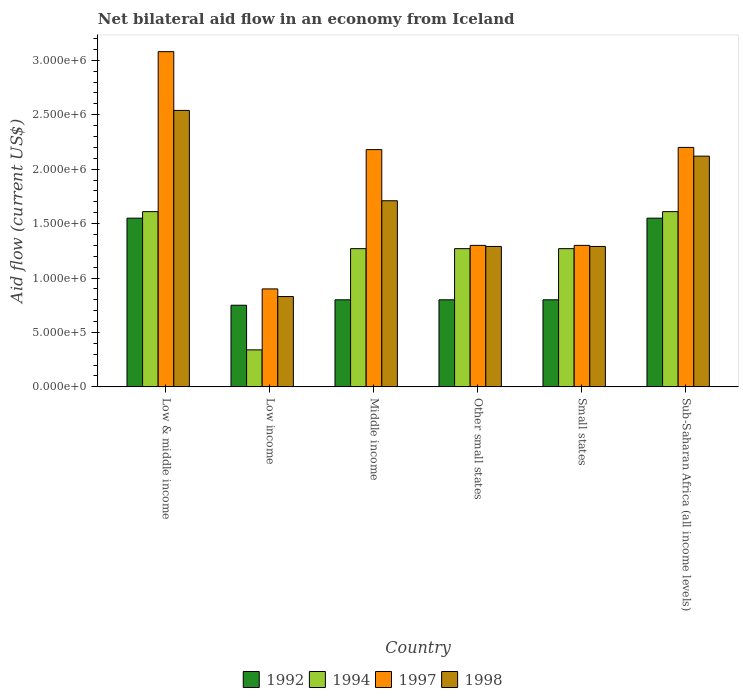How many groups of bars are there?
Provide a succinct answer. 6. Are the number of bars per tick equal to the number of legend labels?
Your answer should be compact. Yes. Are the number of bars on each tick of the X-axis equal?
Your response must be concise. Yes. How many bars are there on the 6th tick from the left?
Offer a terse response. 4. What is the label of the 5th group of bars from the left?
Your answer should be very brief. Small states. What is the net bilateral aid flow in 1997 in Small states?
Give a very brief answer. 1.30e+06. Across all countries, what is the maximum net bilateral aid flow in 1994?
Give a very brief answer. 1.61e+06. Across all countries, what is the minimum net bilateral aid flow in 1992?
Keep it short and to the point. 7.50e+05. What is the total net bilateral aid flow in 1992 in the graph?
Provide a succinct answer. 6.25e+06. What is the difference between the net bilateral aid flow in 1994 in Middle income and that in Other small states?
Keep it short and to the point. 0. What is the average net bilateral aid flow in 1997 per country?
Make the answer very short. 1.83e+06. What is the difference between the net bilateral aid flow of/in 1998 and net bilateral aid flow of/in 1997 in Low income?
Make the answer very short. -7.00e+04. What is the ratio of the net bilateral aid flow in 1992 in Middle income to that in Sub-Saharan Africa (all income levels)?
Your response must be concise. 0.52. Is the difference between the net bilateral aid flow in 1998 in Low income and Small states greater than the difference between the net bilateral aid flow in 1997 in Low income and Small states?
Offer a terse response. No. What is the difference between the highest and the second highest net bilateral aid flow in 1998?
Offer a very short reply. 4.20e+05. What is the difference between the highest and the lowest net bilateral aid flow in 1998?
Your response must be concise. 1.71e+06. In how many countries, is the net bilateral aid flow in 1994 greater than the average net bilateral aid flow in 1994 taken over all countries?
Offer a terse response. 5. Is it the case that in every country, the sum of the net bilateral aid flow in 1998 and net bilateral aid flow in 1997 is greater than the sum of net bilateral aid flow in 1992 and net bilateral aid flow in 1994?
Keep it short and to the point. No. What does the 1st bar from the left in Other small states represents?
Make the answer very short. 1992. What does the 4th bar from the right in Low income represents?
Ensure brevity in your answer.  1992. How many countries are there in the graph?
Your response must be concise. 6. What is the difference between two consecutive major ticks on the Y-axis?
Your answer should be very brief. 5.00e+05. How many legend labels are there?
Provide a succinct answer. 4. What is the title of the graph?
Give a very brief answer. Net bilateral aid flow in an economy from Iceland. What is the label or title of the X-axis?
Your answer should be very brief. Country. What is the Aid flow (current US$) of 1992 in Low & middle income?
Your answer should be very brief. 1.55e+06. What is the Aid flow (current US$) of 1994 in Low & middle income?
Provide a short and direct response. 1.61e+06. What is the Aid flow (current US$) in 1997 in Low & middle income?
Your response must be concise. 3.08e+06. What is the Aid flow (current US$) in 1998 in Low & middle income?
Offer a very short reply. 2.54e+06. What is the Aid flow (current US$) in 1992 in Low income?
Provide a succinct answer. 7.50e+05. What is the Aid flow (current US$) of 1994 in Low income?
Give a very brief answer. 3.40e+05. What is the Aid flow (current US$) in 1997 in Low income?
Make the answer very short. 9.00e+05. What is the Aid flow (current US$) of 1998 in Low income?
Your response must be concise. 8.30e+05. What is the Aid flow (current US$) of 1994 in Middle income?
Your answer should be very brief. 1.27e+06. What is the Aid flow (current US$) of 1997 in Middle income?
Ensure brevity in your answer.  2.18e+06. What is the Aid flow (current US$) of 1998 in Middle income?
Offer a very short reply. 1.71e+06. What is the Aid flow (current US$) of 1992 in Other small states?
Keep it short and to the point. 8.00e+05. What is the Aid flow (current US$) in 1994 in Other small states?
Keep it short and to the point. 1.27e+06. What is the Aid flow (current US$) of 1997 in Other small states?
Keep it short and to the point. 1.30e+06. What is the Aid flow (current US$) of 1998 in Other small states?
Make the answer very short. 1.29e+06. What is the Aid flow (current US$) in 1992 in Small states?
Your response must be concise. 8.00e+05. What is the Aid flow (current US$) of 1994 in Small states?
Give a very brief answer. 1.27e+06. What is the Aid flow (current US$) of 1997 in Small states?
Keep it short and to the point. 1.30e+06. What is the Aid flow (current US$) in 1998 in Small states?
Give a very brief answer. 1.29e+06. What is the Aid flow (current US$) of 1992 in Sub-Saharan Africa (all income levels)?
Offer a terse response. 1.55e+06. What is the Aid flow (current US$) of 1994 in Sub-Saharan Africa (all income levels)?
Provide a succinct answer. 1.61e+06. What is the Aid flow (current US$) in 1997 in Sub-Saharan Africa (all income levels)?
Provide a succinct answer. 2.20e+06. What is the Aid flow (current US$) of 1998 in Sub-Saharan Africa (all income levels)?
Provide a succinct answer. 2.12e+06. Across all countries, what is the maximum Aid flow (current US$) of 1992?
Offer a terse response. 1.55e+06. Across all countries, what is the maximum Aid flow (current US$) in 1994?
Give a very brief answer. 1.61e+06. Across all countries, what is the maximum Aid flow (current US$) of 1997?
Give a very brief answer. 3.08e+06. Across all countries, what is the maximum Aid flow (current US$) of 1998?
Give a very brief answer. 2.54e+06. Across all countries, what is the minimum Aid flow (current US$) in 1992?
Provide a short and direct response. 7.50e+05. Across all countries, what is the minimum Aid flow (current US$) of 1994?
Give a very brief answer. 3.40e+05. Across all countries, what is the minimum Aid flow (current US$) in 1998?
Your answer should be compact. 8.30e+05. What is the total Aid flow (current US$) in 1992 in the graph?
Give a very brief answer. 6.25e+06. What is the total Aid flow (current US$) of 1994 in the graph?
Offer a terse response. 7.37e+06. What is the total Aid flow (current US$) of 1997 in the graph?
Your answer should be compact. 1.10e+07. What is the total Aid flow (current US$) of 1998 in the graph?
Offer a very short reply. 9.78e+06. What is the difference between the Aid flow (current US$) of 1994 in Low & middle income and that in Low income?
Provide a short and direct response. 1.27e+06. What is the difference between the Aid flow (current US$) of 1997 in Low & middle income and that in Low income?
Offer a terse response. 2.18e+06. What is the difference between the Aid flow (current US$) of 1998 in Low & middle income and that in Low income?
Your answer should be very brief. 1.71e+06. What is the difference between the Aid flow (current US$) in 1992 in Low & middle income and that in Middle income?
Provide a short and direct response. 7.50e+05. What is the difference between the Aid flow (current US$) in 1994 in Low & middle income and that in Middle income?
Ensure brevity in your answer.  3.40e+05. What is the difference between the Aid flow (current US$) in 1997 in Low & middle income and that in Middle income?
Offer a very short reply. 9.00e+05. What is the difference between the Aid flow (current US$) in 1998 in Low & middle income and that in Middle income?
Give a very brief answer. 8.30e+05. What is the difference between the Aid flow (current US$) in 1992 in Low & middle income and that in Other small states?
Your answer should be very brief. 7.50e+05. What is the difference between the Aid flow (current US$) in 1994 in Low & middle income and that in Other small states?
Make the answer very short. 3.40e+05. What is the difference between the Aid flow (current US$) of 1997 in Low & middle income and that in Other small states?
Provide a succinct answer. 1.78e+06. What is the difference between the Aid flow (current US$) in 1998 in Low & middle income and that in Other small states?
Your answer should be compact. 1.25e+06. What is the difference between the Aid flow (current US$) of 1992 in Low & middle income and that in Small states?
Provide a short and direct response. 7.50e+05. What is the difference between the Aid flow (current US$) of 1997 in Low & middle income and that in Small states?
Ensure brevity in your answer.  1.78e+06. What is the difference between the Aid flow (current US$) of 1998 in Low & middle income and that in Small states?
Keep it short and to the point. 1.25e+06. What is the difference between the Aid flow (current US$) of 1997 in Low & middle income and that in Sub-Saharan Africa (all income levels)?
Offer a very short reply. 8.80e+05. What is the difference between the Aid flow (current US$) in 1998 in Low & middle income and that in Sub-Saharan Africa (all income levels)?
Keep it short and to the point. 4.20e+05. What is the difference between the Aid flow (current US$) in 1992 in Low income and that in Middle income?
Your answer should be compact. -5.00e+04. What is the difference between the Aid flow (current US$) of 1994 in Low income and that in Middle income?
Ensure brevity in your answer.  -9.30e+05. What is the difference between the Aid flow (current US$) in 1997 in Low income and that in Middle income?
Provide a succinct answer. -1.28e+06. What is the difference between the Aid flow (current US$) of 1998 in Low income and that in Middle income?
Make the answer very short. -8.80e+05. What is the difference between the Aid flow (current US$) in 1992 in Low income and that in Other small states?
Provide a short and direct response. -5.00e+04. What is the difference between the Aid flow (current US$) of 1994 in Low income and that in Other small states?
Provide a short and direct response. -9.30e+05. What is the difference between the Aid flow (current US$) of 1997 in Low income and that in Other small states?
Offer a terse response. -4.00e+05. What is the difference between the Aid flow (current US$) in 1998 in Low income and that in Other small states?
Your answer should be compact. -4.60e+05. What is the difference between the Aid flow (current US$) in 1994 in Low income and that in Small states?
Offer a very short reply. -9.30e+05. What is the difference between the Aid flow (current US$) in 1997 in Low income and that in Small states?
Your answer should be compact. -4.00e+05. What is the difference between the Aid flow (current US$) in 1998 in Low income and that in Small states?
Provide a succinct answer. -4.60e+05. What is the difference between the Aid flow (current US$) of 1992 in Low income and that in Sub-Saharan Africa (all income levels)?
Make the answer very short. -8.00e+05. What is the difference between the Aid flow (current US$) in 1994 in Low income and that in Sub-Saharan Africa (all income levels)?
Ensure brevity in your answer.  -1.27e+06. What is the difference between the Aid flow (current US$) in 1997 in Low income and that in Sub-Saharan Africa (all income levels)?
Offer a terse response. -1.30e+06. What is the difference between the Aid flow (current US$) of 1998 in Low income and that in Sub-Saharan Africa (all income levels)?
Give a very brief answer. -1.29e+06. What is the difference between the Aid flow (current US$) of 1992 in Middle income and that in Other small states?
Ensure brevity in your answer.  0. What is the difference between the Aid flow (current US$) in 1997 in Middle income and that in Other small states?
Keep it short and to the point. 8.80e+05. What is the difference between the Aid flow (current US$) of 1998 in Middle income and that in Other small states?
Ensure brevity in your answer.  4.20e+05. What is the difference between the Aid flow (current US$) in 1992 in Middle income and that in Small states?
Offer a terse response. 0. What is the difference between the Aid flow (current US$) in 1994 in Middle income and that in Small states?
Provide a short and direct response. 0. What is the difference between the Aid flow (current US$) in 1997 in Middle income and that in Small states?
Your answer should be compact. 8.80e+05. What is the difference between the Aid flow (current US$) of 1992 in Middle income and that in Sub-Saharan Africa (all income levels)?
Your answer should be compact. -7.50e+05. What is the difference between the Aid flow (current US$) in 1998 in Middle income and that in Sub-Saharan Africa (all income levels)?
Offer a very short reply. -4.10e+05. What is the difference between the Aid flow (current US$) in 1994 in Other small states and that in Small states?
Provide a short and direct response. 0. What is the difference between the Aid flow (current US$) in 1997 in Other small states and that in Small states?
Give a very brief answer. 0. What is the difference between the Aid flow (current US$) in 1992 in Other small states and that in Sub-Saharan Africa (all income levels)?
Give a very brief answer. -7.50e+05. What is the difference between the Aid flow (current US$) of 1997 in Other small states and that in Sub-Saharan Africa (all income levels)?
Offer a very short reply. -9.00e+05. What is the difference between the Aid flow (current US$) in 1998 in Other small states and that in Sub-Saharan Africa (all income levels)?
Provide a succinct answer. -8.30e+05. What is the difference between the Aid flow (current US$) of 1992 in Small states and that in Sub-Saharan Africa (all income levels)?
Give a very brief answer. -7.50e+05. What is the difference between the Aid flow (current US$) of 1997 in Small states and that in Sub-Saharan Africa (all income levels)?
Your answer should be very brief. -9.00e+05. What is the difference between the Aid flow (current US$) of 1998 in Small states and that in Sub-Saharan Africa (all income levels)?
Your answer should be compact. -8.30e+05. What is the difference between the Aid flow (current US$) in 1992 in Low & middle income and the Aid flow (current US$) in 1994 in Low income?
Your answer should be very brief. 1.21e+06. What is the difference between the Aid flow (current US$) of 1992 in Low & middle income and the Aid flow (current US$) of 1997 in Low income?
Offer a terse response. 6.50e+05. What is the difference between the Aid flow (current US$) of 1992 in Low & middle income and the Aid flow (current US$) of 1998 in Low income?
Give a very brief answer. 7.20e+05. What is the difference between the Aid flow (current US$) in 1994 in Low & middle income and the Aid flow (current US$) in 1997 in Low income?
Offer a terse response. 7.10e+05. What is the difference between the Aid flow (current US$) of 1994 in Low & middle income and the Aid flow (current US$) of 1998 in Low income?
Offer a very short reply. 7.80e+05. What is the difference between the Aid flow (current US$) of 1997 in Low & middle income and the Aid flow (current US$) of 1998 in Low income?
Keep it short and to the point. 2.25e+06. What is the difference between the Aid flow (current US$) in 1992 in Low & middle income and the Aid flow (current US$) in 1994 in Middle income?
Offer a terse response. 2.80e+05. What is the difference between the Aid flow (current US$) in 1992 in Low & middle income and the Aid flow (current US$) in 1997 in Middle income?
Provide a succinct answer. -6.30e+05. What is the difference between the Aid flow (current US$) of 1992 in Low & middle income and the Aid flow (current US$) of 1998 in Middle income?
Provide a short and direct response. -1.60e+05. What is the difference between the Aid flow (current US$) of 1994 in Low & middle income and the Aid flow (current US$) of 1997 in Middle income?
Offer a very short reply. -5.70e+05. What is the difference between the Aid flow (current US$) of 1994 in Low & middle income and the Aid flow (current US$) of 1998 in Middle income?
Keep it short and to the point. -1.00e+05. What is the difference between the Aid flow (current US$) of 1997 in Low & middle income and the Aid flow (current US$) of 1998 in Middle income?
Provide a succinct answer. 1.37e+06. What is the difference between the Aid flow (current US$) of 1992 in Low & middle income and the Aid flow (current US$) of 1994 in Other small states?
Offer a terse response. 2.80e+05. What is the difference between the Aid flow (current US$) in 1992 in Low & middle income and the Aid flow (current US$) in 1997 in Other small states?
Make the answer very short. 2.50e+05. What is the difference between the Aid flow (current US$) in 1992 in Low & middle income and the Aid flow (current US$) in 1998 in Other small states?
Provide a succinct answer. 2.60e+05. What is the difference between the Aid flow (current US$) in 1994 in Low & middle income and the Aid flow (current US$) in 1998 in Other small states?
Make the answer very short. 3.20e+05. What is the difference between the Aid flow (current US$) in 1997 in Low & middle income and the Aid flow (current US$) in 1998 in Other small states?
Your answer should be very brief. 1.79e+06. What is the difference between the Aid flow (current US$) in 1997 in Low & middle income and the Aid flow (current US$) in 1998 in Small states?
Ensure brevity in your answer.  1.79e+06. What is the difference between the Aid flow (current US$) of 1992 in Low & middle income and the Aid flow (current US$) of 1997 in Sub-Saharan Africa (all income levels)?
Make the answer very short. -6.50e+05. What is the difference between the Aid flow (current US$) of 1992 in Low & middle income and the Aid flow (current US$) of 1998 in Sub-Saharan Africa (all income levels)?
Keep it short and to the point. -5.70e+05. What is the difference between the Aid flow (current US$) in 1994 in Low & middle income and the Aid flow (current US$) in 1997 in Sub-Saharan Africa (all income levels)?
Make the answer very short. -5.90e+05. What is the difference between the Aid flow (current US$) in 1994 in Low & middle income and the Aid flow (current US$) in 1998 in Sub-Saharan Africa (all income levels)?
Provide a short and direct response. -5.10e+05. What is the difference between the Aid flow (current US$) in 1997 in Low & middle income and the Aid flow (current US$) in 1998 in Sub-Saharan Africa (all income levels)?
Make the answer very short. 9.60e+05. What is the difference between the Aid flow (current US$) in 1992 in Low income and the Aid flow (current US$) in 1994 in Middle income?
Provide a succinct answer. -5.20e+05. What is the difference between the Aid flow (current US$) of 1992 in Low income and the Aid flow (current US$) of 1997 in Middle income?
Provide a succinct answer. -1.43e+06. What is the difference between the Aid flow (current US$) in 1992 in Low income and the Aid flow (current US$) in 1998 in Middle income?
Give a very brief answer. -9.60e+05. What is the difference between the Aid flow (current US$) of 1994 in Low income and the Aid flow (current US$) of 1997 in Middle income?
Your response must be concise. -1.84e+06. What is the difference between the Aid flow (current US$) in 1994 in Low income and the Aid flow (current US$) in 1998 in Middle income?
Provide a short and direct response. -1.37e+06. What is the difference between the Aid flow (current US$) of 1997 in Low income and the Aid flow (current US$) of 1998 in Middle income?
Offer a very short reply. -8.10e+05. What is the difference between the Aid flow (current US$) in 1992 in Low income and the Aid flow (current US$) in 1994 in Other small states?
Provide a short and direct response. -5.20e+05. What is the difference between the Aid flow (current US$) of 1992 in Low income and the Aid flow (current US$) of 1997 in Other small states?
Offer a terse response. -5.50e+05. What is the difference between the Aid flow (current US$) of 1992 in Low income and the Aid flow (current US$) of 1998 in Other small states?
Offer a terse response. -5.40e+05. What is the difference between the Aid flow (current US$) in 1994 in Low income and the Aid flow (current US$) in 1997 in Other small states?
Ensure brevity in your answer.  -9.60e+05. What is the difference between the Aid flow (current US$) in 1994 in Low income and the Aid flow (current US$) in 1998 in Other small states?
Give a very brief answer. -9.50e+05. What is the difference between the Aid flow (current US$) of 1997 in Low income and the Aid flow (current US$) of 1998 in Other small states?
Provide a short and direct response. -3.90e+05. What is the difference between the Aid flow (current US$) in 1992 in Low income and the Aid flow (current US$) in 1994 in Small states?
Your answer should be very brief. -5.20e+05. What is the difference between the Aid flow (current US$) in 1992 in Low income and the Aid flow (current US$) in 1997 in Small states?
Make the answer very short. -5.50e+05. What is the difference between the Aid flow (current US$) in 1992 in Low income and the Aid flow (current US$) in 1998 in Small states?
Provide a succinct answer. -5.40e+05. What is the difference between the Aid flow (current US$) of 1994 in Low income and the Aid flow (current US$) of 1997 in Small states?
Make the answer very short. -9.60e+05. What is the difference between the Aid flow (current US$) of 1994 in Low income and the Aid flow (current US$) of 1998 in Small states?
Your answer should be compact. -9.50e+05. What is the difference between the Aid flow (current US$) of 1997 in Low income and the Aid flow (current US$) of 1998 in Small states?
Provide a short and direct response. -3.90e+05. What is the difference between the Aid flow (current US$) of 1992 in Low income and the Aid flow (current US$) of 1994 in Sub-Saharan Africa (all income levels)?
Your response must be concise. -8.60e+05. What is the difference between the Aid flow (current US$) of 1992 in Low income and the Aid flow (current US$) of 1997 in Sub-Saharan Africa (all income levels)?
Provide a succinct answer. -1.45e+06. What is the difference between the Aid flow (current US$) in 1992 in Low income and the Aid flow (current US$) in 1998 in Sub-Saharan Africa (all income levels)?
Make the answer very short. -1.37e+06. What is the difference between the Aid flow (current US$) of 1994 in Low income and the Aid flow (current US$) of 1997 in Sub-Saharan Africa (all income levels)?
Provide a short and direct response. -1.86e+06. What is the difference between the Aid flow (current US$) of 1994 in Low income and the Aid flow (current US$) of 1998 in Sub-Saharan Africa (all income levels)?
Provide a short and direct response. -1.78e+06. What is the difference between the Aid flow (current US$) of 1997 in Low income and the Aid flow (current US$) of 1998 in Sub-Saharan Africa (all income levels)?
Offer a very short reply. -1.22e+06. What is the difference between the Aid flow (current US$) in 1992 in Middle income and the Aid flow (current US$) in 1994 in Other small states?
Keep it short and to the point. -4.70e+05. What is the difference between the Aid flow (current US$) in 1992 in Middle income and the Aid flow (current US$) in 1997 in Other small states?
Give a very brief answer. -5.00e+05. What is the difference between the Aid flow (current US$) of 1992 in Middle income and the Aid flow (current US$) of 1998 in Other small states?
Your response must be concise. -4.90e+05. What is the difference between the Aid flow (current US$) of 1994 in Middle income and the Aid flow (current US$) of 1998 in Other small states?
Your answer should be very brief. -2.00e+04. What is the difference between the Aid flow (current US$) in 1997 in Middle income and the Aid flow (current US$) in 1998 in Other small states?
Offer a terse response. 8.90e+05. What is the difference between the Aid flow (current US$) of 1992 in Middle income and the Aid flow (current US$) of 1994 in Small states?
Make the answer very short. -4.70e+05. What is the difference between the Aid flow (current US$) of 1992 in Middle income and the Aid flow (current US$) of 1997 in Small states?
Keep it short and to the point. -5.00e+05. What is the difference between the Aid flow (current US$) of 1992 in Middle income and the Aid flow (current US$) of 1998 in Small states?
Ensure brevity in your answer.  -4.90e+05. What is the difference between the Aid flow (current US$) in 1994 in Middle income and the Aid flow (current US$) in 1997 in Small states?
Your response must be concise. -3.00e+04. What is the difference between the Aid flow (current US$) of 1994 in Middle income and the Aid flow (current US$) of 1998 in Small states?
Your answer should be very brief. -2.00e+04. What is the difference between the Aid flow (current US$) in 1997 in Middle income and the Aid flow (current US$) in 1998 in Small states?
Your answer should be compact. 8.90e+05. What is the difference between the Aid flow (current US$) of 1992 in Middle income and the Aid flow (current US$) of 1994 in Sub-Saharan Africa (all income levels)?
Keep it short and to the point. -8.10e+05. What is the difference between the Aid flow (current US$) of 1992 in Middle income and the Aid flow (current US$) of 1997 in Sub-Saharan Africa (all income levels)?
Your response must be concise. -1.40e+06. What is the difference between the Aid flow (current US$) of 1992 in Middle income and the Aid flow (current US$) of 1998 in Sub-Saharan Africa (all income levels)?
Offer a terse response. -1.32e+06. What is the difference between the Aid flow (current US$) of 1994 in Middle income and the Aid flow (current US$) of 1997 in Sub-Saharan Africa (all income levels)?
Give a very brief answer. -9.30e+05. What is the difference between the Aid flow (current US$) in 1994 in Middle income and the Aid flow (current US$) in 1998 in Sub-Saharan Africa (all income levels)?
Provide a short and direct response. -8.50e+05. What is the difference between the Aid flow (current US$) of 1992 in Other small states and the Aid flow (current US$) of 1994 in Small states?
Make the answer very short. -4.70e+05. What is the difference between the Aid flow (current US$) in 1992 in Other small states and the Aid flow (current US$) in 1997 in Small states?
Ensure brevity in your answer.  -5.00e+05. What is the difference between the Aid flow (current US$) in 1992 in Other small states and the Aid flow (current US$) in 1998 in Small states?
Your response must be concise. -4.90e+05. What is the difference between the Aid flow (current US$) in 1992 in Other small states and the Aid flow (current US$) in 1994 in Sub-Saharan Africa (all income levels)?
Make the answer very short. -8.10e+05. What is the difference between the Aid flow (current US$) of 1992 in Other small states and the Aid flow (current US$) of 1997 in Sub-Saharan Africa (all income levels)?
Keep it short and to the point. -1.40e+06. What is the difference between the Aid flow (current US$) of 1992 in Other small states and the Aid flow (current US$) of 1998 in Sub-Saharan Africa (all income levels)?
Offer a terse response. -1.32e+06. What is the difference between the Aid flow (current US$) of 1994 in Other small states and the Aid flow (current US$) of 1997 in Sub-Saharan Africa (all income levels)?
Your answer should be very brief. -9.30e+05. What is the difference between the Aid flow (current US$) in 1994 in Other small states and the Aid flow (current US$) in 1998 in Sub-Saharan Africa (all income levels)?
Offer a very short reply. -8.50e+05. What is the difference between the Aid flow (current US$) of 1997 in Other small states and the Aid flow (current US$) of 1998 in Sub-Saharan Africa (all income levels)?
Keep it short and to the point. -8.20e+05. What is the difference between the Aid flow (current US$) of 1992 in Small states and the Aid flow (current US$) of 1994 in Sub-Saharan Africa (all income levels)?
Ensure brevity in your answer.  -8.10e+05. What is the difference between the Aid flow (current US$) of 1992 in Small states and the Aid flow (current US$) of 1997 in Sub-Saharan Africa (all income levels)?
Your answer should be compact. -1.40e+06. What is the difference between the Aid flow (current US$) in 1992 in Small states and the Aid flow (current US$) in 1998 in Sub-Saharan Africa (all income levels)?
Make the answer very short. -1.32e+06. What is the difference between the Aid flow (current US$) of 1994 in Small states and the Aid flow (current US$) of 1997 in Sub-Saharan Africa (all income levels)?
Your answer should be compact. -9.30e+05. What is the difference between the Aid flow (current US$) of 1994 in Small states and the Aid flow (current US$) of 1998 in Sub-Saharan Africa (all income levels)?
Keep it short and to the point. -8.50e+05. What is the difference between the Aid flow (current US$) in 1997 in Small states and the Aid flow (current US$) in 1998 in Sub-Saharan Africa (all income levels)?
Your answer should be very brief. -8.20e+05. What is the average Aid flow (current US$) in 1992 per country?
Provide a succinct answer. 1.04e+06. What is the average Aid flow (current US$) in 1994 per country?
Give a very brief answer. 1.23e+06. What is the average Aid flow (current US$) in 1997 per country?
Provide a succinct answer. 1.83e+06. What is the average Aid flow (current US$) in 1998 per country?
Your response must be concise. 1.63e+06. What is the difference between the Aid flow (current US$) of 1992 and Aid flow (current US$) of 1994 in Low & middle income?
Provide a short and direct response. -6.00e+04. What is the difference between the Aid flow (current US$) in 1992 and Aid flow (current US$) in 1997 in Low & middle income?
Keep it short and to the point. -1.53e+06. What is the difference between the Aid flow (current US$) of 1992 and Aid flow (current US$) of 1998 in Low & middle income?
Offer a terse response. -9.90e+05. What is the difference between the Aid flow (current US$) in 1994 and Aid flow (current US$) in 1997 in Low & middle income?
Give a very brief answer. -1.47e+06. What is the difference between the Aid flow (current US$) in 1994 and Aid flow (current US$) in 1998 in Low & middle income?
Keep it short and to the point. -9.30e+05. What is the difference between the Aid flow (current US$) of 1997 and Aid flow (current US$) of 1998 in Low & middle income?
Provide a succinct answer. 5.40e+05. What is the difference between the Aid flow (current US$) of 1992 and Aid flow (current US$) of 1994 in Low income?
Your response must be concise. 4.10e+05. What is the difference between the Aid flow (current US$) of 1992 and Aid flow (current US$) of 1997 in Low income?
Your answer should be very brief. -1.50e+05. What is the difference between the Aid flow (current US$) of 1992 and Aid flow (current US$) of 1998 in Low income?
Provide a succinct answer. -8.00e+04. What is the difference between the Aid flow (current US$) of 1994 and Aid flow (current US$) of 1997 in Low income?
Your response must be concise. -5.60e+05. What is the difference between the Aid flow (current US$) in 1994 and Aid flow (current US$) in 1998 in Low income?
Give a very brief answer. -4.90e+05. What is the difference between the Aid flow (current US$) of 1992 and Aid flow (current US$) of 1994 in Middle income?
Your response must be concise. -4.70e+05. What is the difference between the Aid flow (current US$) of 1992 and Aid flow (current US$) of 1997 in Middle income?
Provide a succinct answer. -1.38e+06. What is the difference between the Aid flow (current US$) in 1992 and Aid flow (current US$) in 1998 in Middle income?
Provide a short and direct response. -9.10e+05. What is the difference between the Aid flow (current US$) of 1994 and Aid flow (current US$) of 1997 in Middle income?
Give a very brief answer. -9.10e+05. What is the difference between the Aid flow (current US$) in 1994 and Aid flow (current US$) in 1998 in Middle income?
Your answer should be compact. -4.40e+05. What is the difference between the Aid flow (current US$) in 1997 and Aid flow (current US$) in 1998 in Middle income?
Make the answer very short. 4.70e+05. What is the difference between the Aid flow (current US$) of 1992 and Aid flow (current US$) of 1994 in Other small states?
Offer a very short reply. -4.70e+05. What is the difference between the Aid flow (current US$) in 1992 and Aid flow (current US$) in 1997 in Other small states?
Your answer should be very brief. -5.00e+05. What is the difference between the Aid flow (current US$) of 1992 and Aid flow (current US$) of 1998 in Other small states?
Your answer should be compact. -4.90e+05. What is the difference between the Aid flow (current US$) of 1994 and Aid flow (current US$) of 1998 in Other small states?
Make the answer very short. -2.00e+04. What is the difference between the Aid flow (current US$) of 1997 and Aid flow (current US$) of 1998 in Other small states?
Your answer should be very brief. 10000. What is the difference between the Aid flow (current US$) in 1992 and Aid flow (current US$) in 1994 in Small states?
Your response must be concise. -4.70e+05. What is the difference between the Aid flow (current US$) of 1992 and Aid flow (current US$) of 1997 in Small states?
Make the answer very short. -5.00e+05. What is the difference between the Aid flow (current US$) in 1992 and Aid flow (current US$) in 1998 in Small states?
Provide a short and direct response. -4.90e+05. What is the difference between the Aid flow (current US$) of 1994 and Aid flow (current US$) of 1997 in Small states?
Provide a short and direct response. -3.00e+04. What is the difference between the Aid flow (current US$) of 1994 and Aid flow (current US$) of 1998 in Small states?
Ensure brevity in your answer.  -2.00e+04. What is the difference between the Aid flow (current US$) of 1997 and Aid flow (current US$) of 1998 in Small states?
Provide a short and direct response. 10000. What is the difference between the Aid flow (current US$) of 1992 and Aid flow (current US$) of 1997 in Sub-Saharan Africa (all income levels)?
Your response must be concise. -6.50e+05. What is the difference between the Aid flow (current US$) of 1992 and Aid flow (current US$) of 1998 in Sub-Saharan Africa (all income levels)?
Offer a terse response. -5.70e+05. What is the difference between the Aid flow (current US$) of 1994 and Aid flow (current US$) of 1997 in Sub-Saharan Africa (all income levels)?
Offer a very short reply. -5.90e+05. What is the difference between the Aid flow (current US$) of 1994 and Aid flow (current US$) of 1998 in Sub-Saharan Africa (all income levels)?
Give a very brief answer. -5.10e+05. What is the difference between the Aid flow (current US$) of 1997 and Aid flow (current US$) of 1998 in Sub-Saharan Africa (all income levels)?
Keep it short and to the point. 8.00e+04. What is the ratio of the Aid flow (current US$) of 1992 in Low & middle income to that in Low income?
Your response must be concise. 2.07. What is the ratio of the Aid flow (current US$) of 1994 in Low & middle income to that in Low income?
Provide a succinct answer. 4.74. What is the ratio of the Aid flow (current US$) in 1997 in Low & middle income to that in Low income?
Your response must be concise. 3.42. What is the ratio of the Aid flow (current US$) in 1998 in Low & middle income to that in Low income?
Provide a succinct answer. 3.06. What is the ratio of the Aid flow (current US$) in 1992 in Low & middle income to that in Middle income?
Make the answer very short. 1.94. What is the ratio of the Aid flow (current US$) in 1994 in Low & middle income to that in Middle income?
Your answer should be very brief. 1.27. What is the ratio of the Aid flow (current US$) in 1997 in Low & middle income to that in Middle income?
Provide a short and direct response. 1.41. What is the ratio of the Aid flow (current US$) of 1998 in Low & middle income to that in Middle income?
Offer a terse response. 1.49. What is the ratio of the Aid flow (current US$) of 1992 in Low & middle income to that in Other small states?
Provide a succinct answer. 1.94. What is the ratio of the Aid flow (current US$) in 1994 in Low & middle income to that in Other small states?
Provide a short and direct response. 1.27. What is the ratio of the Aid flow (current US$) of 1997 in Low & middle income to that in Other small states?
Provide a succinct answer. 2.37. What is the ratio of the Aid flow (current US$) of 1998 in Low & middle income to that in Other small states?
Keep it short and to the point. 1.97. What is the ratio of the Aid flow (current US$) in 1992 in Low & middle income to that in Small states?
Your answer should be very brief. 1.94. What is the ratio of the Aid flow (current US$) in 1994 in Low & middle income to that in Small states?
Provide a short and direct response. 1.27. What is the ratio of the Aid flow (current US$) in 1997 in Low & middle income to that in Small states?
Your answer should be very brief. 2.37. What is the ratio of the Aid flow (current US$) in 1998 in Low & middle income to that in Small states?
Ensure brevity in your answer.  1.97. What is the ratio of the Aid flow (current US$) of 1992 in Low & middle income to that in Sub-Saharan Africa (all income levels)?
Provide a short and direct response. 1. What is the ratio of the Aid flow (current US$) of 1994 in Low & middle income to that in Sub-Saharan Africa (all income levels)?
Make the answer very short. 1. What is the ratio of the Aid flow (current US$) in 1998 in Low & middle income to that in Sub-Saharan Africa (all income levels)?
Provide a short and direct response. 1.2. What is the ratio of the Aid flow (current US$) in 1994 in Low income to that in Middle income?
Make the answer very short. 0.27. What is the ratio of the Aid flow (current US$) of 1997 in Low income to that in Middle income?
Give a very brief answer. 0.41. What is the ratio of the Aid flow (current US$) in 1998 in Low income to that in Middle income?
Make the answer very short. 0.49. What is the ratio of the Aid flow (current US$) of 1994 in Low income to that in Other small states?
Your response must be concise. 0.27. What is the ratio of the Aid flow (current US$) of 1997 in Low income to that in Other small states?
Give a very brief answer. 0.69. What is the ratio of the Aid flow (current US$) of 1998 in Low income to that in Other small states?
Your response must be concise. 0.64. What is the ratio of the Aid flow (current US$) of 1994 in Low income to that in Small states?
Your answer should be compact. 0.27. What is the ratio of the Aid flow (current US$) in 1997 in Low income to that in Small states?
Keep it short and to the point. 0.69. What is the ratio of the Aid flow (current US$) of 1998 in Low income to that in Small states?
Your answer should be compact. 0.64. What is the ratio of the Aid flow (current US$) in 1992 in Low income to that in Sub-Saharan Africa (all income levels)?
Offer a very short reply. 0.48. What is the ratio of the Aid flow (current US$) in 1994 in Low income to that in Sub-Saharan Africa (all income levels)?
Ensure brevity in your answer.  0.21. What is the ratio of the Aid flow (current US$) of 1997 in Low income to that in Sub-Saharan Africa (all income levels)?
Ensure brevity in your answer.  0.41. What is the ratio of the Aid flow (current US$) in 1998 in Low income to that in Sub-Saharan Africa (all income levels)?
Your answer should be very brief. 0.39. What is the ratio of the Aid flow (current US$) of 1997 in Middle income to that in Other small states?
Provide a short and direct response. 1.68. What is the ratio of the Aid flow (current US$) of 1998 in Middle income to that in Other small states?
Offer a very short reply. 1.33. What is the ratio of the Aid flow (current US$) of 1992 in Middle income to that in Small states?
Offer a terse response. 1. What is the ratio of the Aid flow (current US$) of 1994 in Middle income to that in Small states?
Your answer should be very brief. 1. What is the ratio of the Aid flow (current US$) in 1997 in Middle income to that in Small states?
Offer a very short reply. 1.68. What is the ratio of the Aid flow (current US$) of 1998 in Middle income to that in Small states?
Keep it short and to the point. 1.33. What is the ratio of the Aid flow (current US$) in 1992 in Middle income to that in Sub-Saharan Africa (all income levels)?
Your response must be concise. 0.52. What is the ratio of the Aid flow (current US$) of 1994 in Middle income to that in Sub-Saharan Africa (all income levels)?
Keep it short and to the point. 0.79. What is the ratio of the Aid flow (current US$) of 1997 in Middle income to that in Sub-Saharan Africa (all income levels)?
Your answer should be compact. 0.99. What is the ratio of the Aid flow (current US$) in 1998 in Middle income to that in Sub-Saharan Africa (all income levels)?
Offer a very short reply. 0.81. What is the ratio of the Aid flow (current US$) in 1997 in Other small states to that in Small states?
Offer a very short reply. 1. What is the ratio of the Aid flow (current US$) of 1992 in Other small states to that in Sub-Saharan Africa (all income levels)?
Your answer should be compact. 0.52. What is the ratio of the Aid flow (current US$) of 1994 in Other small states to that in Sub-Saharan Africa (all income levels)?
Give a very brief answer. 0.79. What is the ratio of the Aid flow (current US$) in 1997 in Other small states to that in Sub-Saharan Africa (all income levels)?
Keep it short and to the point. 0.59. What is the ratio of the Aid flow (current US$) of 1998 in Other small states to that in Sub-Saharan Africa (all income levels)?
Your answer should be compact. 0.61. What is the ratio of the Aid flow (current US$) of 1992 in Small states to that in Sub-Saharan Africa (all income levels)?
Make the answer very short. 0.52. What is the ratio of the Aid flow (current US$) of 1994 in Small states to that in Sub-Saharan Africa (all income levels)?
Ensure brevity in your answer.  0.79. What is the ratio of the Aid flow (current US$) in 1997 in Small states to that in Sub-Saharan Africa (all income levels)?
Offer a very short reply. 0.59. What is the ratio of the Aid flow (current US$) of 1998 in Small states to that in Sub-Saharan Africa (all income levels)?
Ensure brevity in your answer.  0.61. What is the difference between the highest and the second highest Aid flow (current US$) in 1997?
Keep it short and to the point. 8.80e+05. What is the difference between the highest and the lowest Aid flow (current US$) of 1992?
Your answer should be compact. 8.00e+05. What is the difference between the highest and the lowest Aid flow (current US$) in 1994?
Your answer should be compact. 1.27e+06. What is the difference between the highest and the lowest Aid flow (current US$) in 1997?
Provide a succinct answer. 2.18e+06. What is the difference between the highest and the lowest Aid flow (current US$) in 1998?
Offer a terse response. 1.71e+06. 